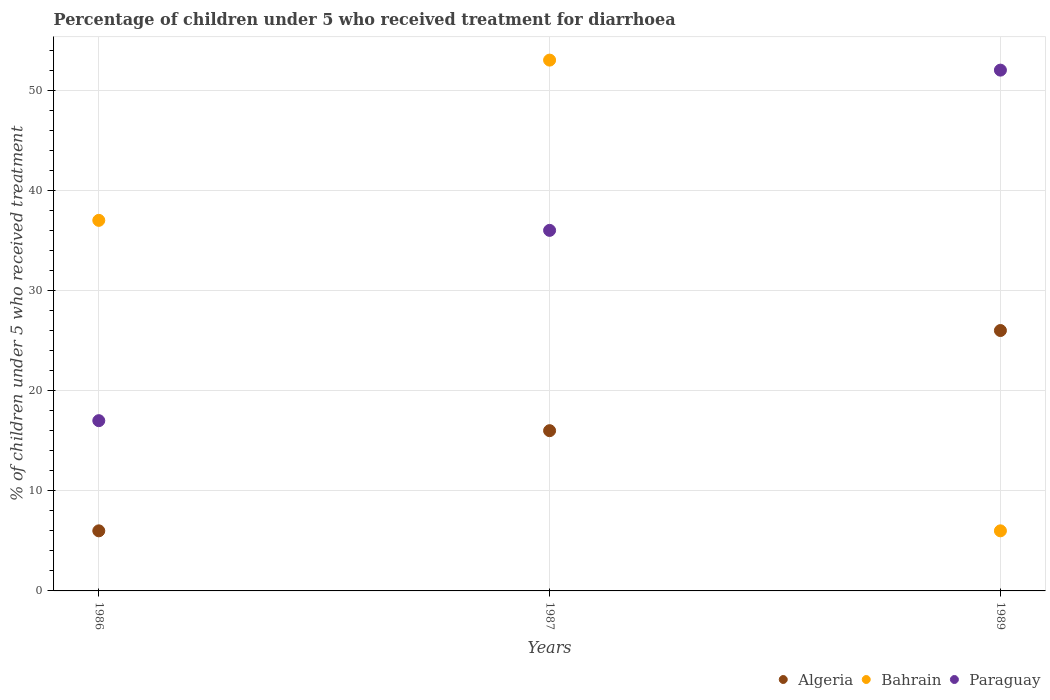Across all years, what is the minimum percentage of children who received treatment for diarrhoea  in Algeria?
Provide a short and direct response. 6. In which year was the percentage of children who received treatment for diarrhoea  in Algeria maximum?
Provide a short and direct response. 1989. In which year was the percentage of children who received treatment for diarrhoea  in Paraguay minimum?
Offer a very short reply. 1986. What is the total percentage of children who received treatment for diarrhoea  in Paraguay in the graph?
Give a very brief answer. 105. What is the difference between the percentage of children who received treatment for diarrhoea  in Bahrain in 1986 and that in 1987?
Your response must be concise. -16. What is the difference between the percentage of children who received treatment for diarrhoea  in Bahrain in 1989 and the percentage of children who received treatment for diarrhoea  in Algeria in 1987?
Provide a short and direct response. -10. In the year 1989, what is the difference between the percentage of children who received treatment for diarrhoea  in Bahrain and percentage of children who received treatment for diarrhoea  in Paraguay?
Provide a succinct answer. -46. In how many years, is the percentage of children who received treatment for diarrhoea  in Algeria greater than 26 %?
Your answer should be very brief. 0. What is the ratio of the percentage of children who received treatment for diarrhoea  in Algeria in 1986 to that in 1987?
Make the answer very short. 0.38. Is the difference between the percentage of children who received treatment for diarrhoea  in Bahrain in 1987 and 1989 greater than the difference between the percentage of children who received treatment for diarrhoea  in Paraguay in 1987 and 1989?
Offer a terse response. Yes. What is the difference between the highest and the second highest percentage of children who received treatment for diarrhoea  in Algeria?
Make the answer very short. 10. In how many years, is the percentage of children who received treatment for diarrhoea  in Algeria greater than the average percentage of children who received treatment for diarrhoea  in Algeria taken over all years?
Give a very brief answer. 1. Is the sum of the percentage of children who received treatment for diarrhoea  in Bahrain in 1986 and 1987 greater than the maximum percentage of children who received treatment for diarrhoea  in Paraguay across all years?
Offer a very short reply. Yes. Does the percentage of children who received treatment for diarrhoea  in Bahrain monotonically increase over the years?
Give a very brief answer. No. Is the percentage of children who received treatment for diarrhoea  in Bahrain strictly greater than the percentage of children who received treatment for diarrhoea  in Paraguay over the years?
Your answer should be compact. No. How many years are there in the graph?
Make the answer very short. 3. What is the difference between two consecutive major ticks on the Y-axis?
Keep it short and to the point. 10. Does the graph contain grids?
Provide a short and direct response. Yes. Where does the legend appear in the graph?
Provide a succinct answer. Bottom right. How many legend labels are there?
Keep it short and to the point. 3. What is the title of the graph?
Offer a terse response. Percentage of children under 5 who received treatment for diarrhoea. What is the label or title of the Y-axis?
Give a very brief answer. % of children under 5 who received treatment. What is the % of children under 5 who received treatment of Algeria in 1986?
Offer a terse response. 6. What is the % of children under 5 who received treatment in Paraguay in 1986?
Keep it short and to the point. 17. What is the % of children under 5 who received treatment in Algeria in 1987?
Keep it short and to the point. 16. What is the % of children under 5 who received treatment in Bahrain in 1987?
Provide a short and direct response. 53. What is the % of children under 5 who received treatment in Algeria in 1989?
Your response must be concise. 26. What is the % of children under 5 who received treatment of Bahrain in 1989?
Provide a short and direct response. 6. Across all years, what is the maximum % of children under 5 who received treatment in Algeria?
Keep it short and to the point. 26. Across all years, what is the maximum % of children under 5 who received treatment in Paraguay?
Offer a terse response. 52. Across all years, what is the minimum % of children under 5 who received treatment of Bahrain?
Your response must be concise. 6. What is the total % of children under 5 who received treatment in Bahrain in the graph?
Provide a succinct answer. 96. What is the total % of children under 5 who received treatment in Paraguay in the graph?
Give a very brief answer. 105. What is the difference between the % of children under 5 who received treatment in Algeria in 1986 and that in 1989?
Offer a very short reply. -20. What is the difference between the % of children under 5 who received treatment in Paraguay in 1986 and that in 1989?
Keep it short and to the point. -35. What is the difference between the % of children under 5 who received treatment of Algeria in 1987 and that in 1989?
Provide a succinct answer. -10. What is the difference between the % of children under 5 who received treatment of Bahrain in 1987 and that in 1989?
Make the answer very short. 47. What is the difference between the % of children under 5 who received treatment in Paraguay in 1987 and that in 1989?
Keep it short and to the point. -16. What is the difference between the % of children under 5 who received treatment in Algeria in 1986 and the % of children under 5 who received treatment in Bahrain in 1987?
Your answer should be compact. -47. What is the difference between the % of children under 5 who received treatment of Algeria in 1986 and the % of children under 5 who received treatment of Paraguay in 1987?
Make the answer very short. -30. What is the difference between the % of children under 5 who received treatment of Bahrain in 1986 and the % of children under 5 who received treatment of Paraguay in 1987?
Your answer should be very brief. 1. What is the difference between the % of children under 5 who received treatment of Algeria in 1986 and the % of children under 5 who received treatment of Bahrain in 1989?
Your response must be concise. 0. What is the difference between the % of children under 5 who received treatment in Algeria in 1986 and the % of children under 5 who received treatment in Paraguay in 1989?
Your answer should be very brief. -46. What is the difference between the % of children under 5 who received treatment of Algeria in 1987 and the % of children under 5 who received treatment of Bahrain in 1989?
Ensure brevity in your answer.  10. What is the difference between the % of children under 5 who received treatment in Algeria in 1987 and the % of children under 5 who received treatment in Paraguay in 1989?
Make the answer very short. -36. What is the average % of children under 5 who received treatment of Algeria per year?
Your response must be concise. 16. What is the average % of children under 5 who received treatment of Bahrain per year?
Give a very brief answer. 32. What is the average % of children under 5 who received treatment in Paraguay per year?
Your answer should be very brief. 35. In the year 1986, what is the difference between the % of children under 5 who received treatment of Algeria and % of children under 5 who received treatment of Bahrain?
Give a very brief answer. -31. In the year 1987, what is the difference between the % of children under 5 who received treatment in Algeria and % of children under 5 who received treatment in Bahrain?
Your answer should be compact. -37. In the year 1989, what is the difference between the % of children under 5 who received treatment of Bahrain and % of children under 5 who received treatment of Paraguay?
Keep it short and to the point. -46. What is the ratio of the % of children under 5 who received treatment in Bahrain in 1986 to that in 1987?
Offer a very short reply. 0.7. What is the ratio of the % of children under 5 who received treatment of Paraguay in 1986 to that in 1987?
Ensure brevity in your answer.  0.47. What is the ratio of the % of children under 5 who received treatment in Algeria in 1986 to that in 1989?
Your response must be concise. 0.23. What is the ratio of the % of children under 5 who received treatment in Bahrain in 1986 to that in 1989?
Your answer should be compact. 6.17. What is the ratio of the % of children under 5 who received treatment of Paraguay in 1986 to that in 1989?
Provide a succinct answer. 0.33. What is the ratio of the % of children under 5 who received treatment in Algeria in 1987 to that in 1989?
Give a very brief answer. 0.62. What is the ratio of the % of children under 5 who received treatment in Bahrain in 1987 to that in 1989?
Offer a terse response. 8.83. What is the ratio of the % of children under 5 who received treatment of Paraguay in 1987 to that in 1989?
Ensure brevity in your answer.  0.69. What is the difference between the highest and the lowest % of children under 5 who received treatment in Algeria?
Give a very brief answer. 20. What is the difference between the highest and the lowest % of children under 5 who received treatment in Paraguay?
Make the answer very short. 35. 